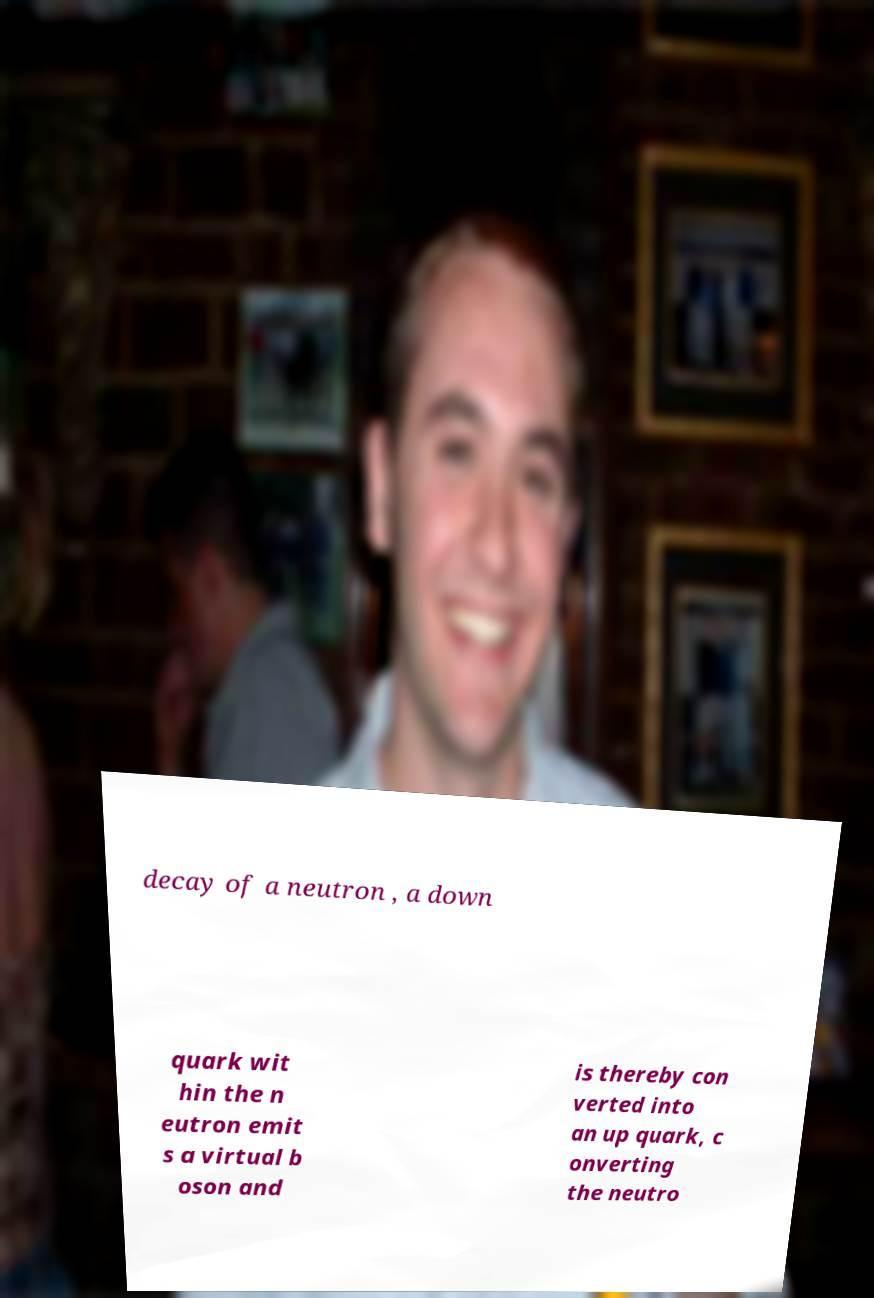Please identify and transcribe the text found in this image. decay of a neutron , a down quark wit hin the n eutron emit s a virtual b oson and is thereby con verted into an up quark, c onverting the neutro 